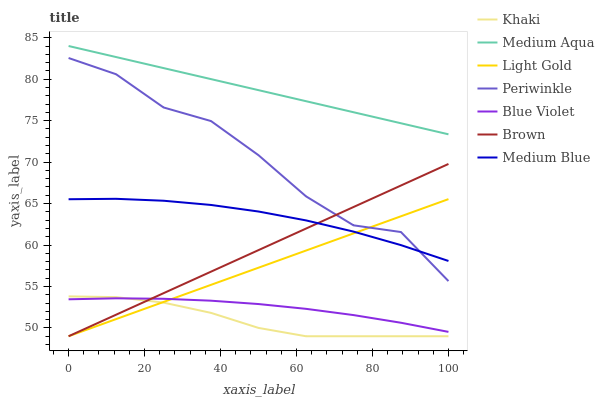Does Khaki have the minimum area under the curve?
Answer yes or no. Yes. Does Medium Aqua have the maximum area under the curve?
Answer yes or no. Yes. Does Medium Blue have the minimum area under the curve?
Answer yes or no. No. Does Medium Blue have the maximum area under the curve?
Answer yes or no. No. Is Brown the smoothest?
Answer yes or no. Yes. Is Periwinkle the roughest?
Answer yes or no. Yes. Is Khaki the smoothest?
Answer yes or no. No. Is Khaki the roughest?
Answer yes or no. No. Does Brown have the lowest value?
Answer yes or no. Yes. Does Medium Blue have the lowest value?
Answer yes or no. No. Does Medium Aqua have the highest value?
Answer yes or no. Yes. Does Khaki have the highest value?
Answer yes or no. No. Is Periwinkle less than Medium Aqua?
Answer yes or no. Yes. Is Medium Blue greater than Blue Violet?
Answer yes or no. Yes. Does Light Gold intersect Blue Violet?
Answer yes or no. Yes. Is Light Gold less than Blue Violet?
Answer yes or no. No. Is Light Gold greater than Blue Violet?
Answer yes or no. No. Does Periwinkle intersect Medium Aqua?
Answer yes or no. No. 